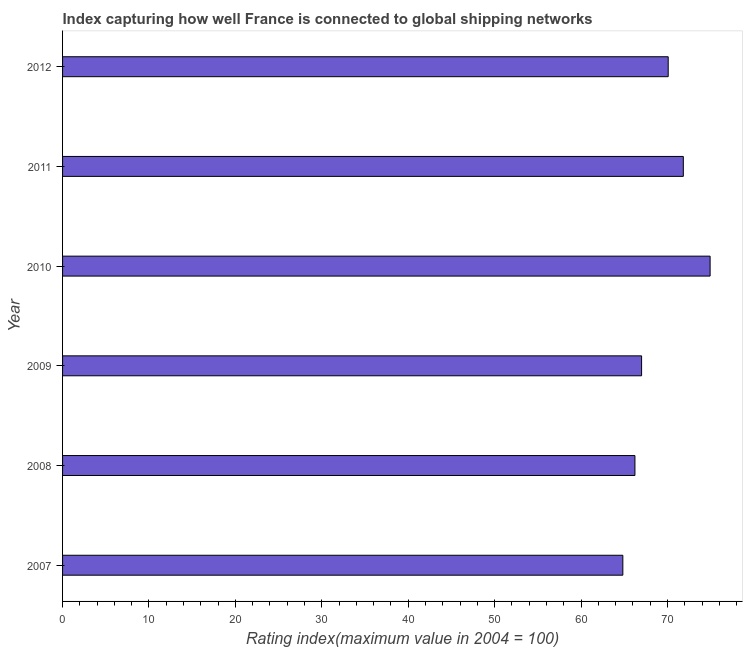Does the graph contain any zero values?
Offer a very short reply. No. What is the title of the graph?
Your answer should be very brief. Index capturing how well France is connected to global shipping networks. What is the label or title of the X-axis?
Ensure brevity in your answer.  Rating index(maximum value in 2004 = 100). What is the label or title of the Y-axis?
Give a very brief answer. Year. What is the liner shipping connectivity index in 2008?
Your response must be concise. 66.24. Across all years, what is the maximum liner shipping connectivity index?
Keep it short and to the point. 74.94. Across all years, what is the minimum liner shipping connectivity index?
Offer a terse response. 64.84. What is the sum of the liner shipping connectivity index?
Your answer should be very brief. 414.96. What is the difference between the liner shipping connectivity index in 2008 and 2012?
Give a very brief answer. -3.85. What is the average liner shipping connectivity index per year?
Provide a short and direct response. 69.16. What is the median liner shipping connectivity index?
Offer a very short reply. 68.55. Do a majority of the years between 2008 and 2007 (inclusive) have liner shipping connectivity index greater than 40 ?
Your answer should be very brief. No. What is the ratio of the liner shipping connectivity index in 2007 to that in 2011?
Give a very brief answer. 0.9. What is the difference between the highest and the second highest liner shipping connectivity index?
Your answer should be compact. 3.1. Is the sum of the liner shipping connectivity index in 2009 and 2011 greater than the maximum liner shipping connectivity index across all years?
Provide a short and direct response. Yes. What is the difference between the highest and the lowest liner shipping connectivity index?
Keep it short and to the point. 10.1. In how many years, is the liner shipping connectivity index greater than the average liner shipping connectivity index taken over all years?
Offer a very short reply. 3. Are all the bars in the graph horizontal?
Your answer should be very brief. Yes. How many years are there in the graph?
Your response must be concise. 6. Are the values on the major ticks of X-axis written in scientific E-notation?
Make the answer very short. No. What is the Rating index(maximum value in 2004 = 100) of 2007?
Offer a very short reply. 64.84. What is the Rating index(maximum value in 2004 = 100) in 2008?
Your answer should be very brief. 66.24. What is the Rating index(maximum value in 2004 = 100) in 2009?
Offer a terse response. 67.01. What is the Rating index(maximum value in 2004 = 100) in 2010?
Provide a succinct answer. 74.94. What is the Rating index(maximum value in 2004 = 100) in 2011?
Provide a succinct answer. 71.84. What is the Rating index(maximum value in 2004 = 100) in 2012?
Offer a very short reply. 70.09. What is the difference between the Rating index(maximum value in 2004 = 100) in 2007 and 2009?
Make the answer very short. -2.17. What is the difference between the Rating index(maximum value in 2004 = 100) in 2007 and 2011?
Ensure brevity in your answer.  -7. What is the difference between the Rating index(maximum value in 2004 = 100) in 2007 and 2012?
Make the answer very short. -5.25. What is the difference between the Rating index(maximum value in 2004 = 100) in 2008 and 2009?
Your response must be concise. -0.77. What is the difference between the Rating index(maximum value in 2004 = 100) in 2008 and 2010?
Offer a terse response. -8.7. What is the difference between the Rating index(maximum value in 2004 = 100) in 2008 and 2012?
Your response must be concise. -3.85. What is the difference between the Rating index(maximum value in 2004 = 100) in 2009 and 2010?
Your answer should be compact. -7.93. What is the difference between the Rating index(maximum value in 2004 = 100) in 2009 and 2011?
Your answer should be very brief. -4.83. What is the difference between the Rating index(maximum value in 2004 = 100) in 2009 and 2012?
Provide a short and direct response. -3.08. What is the difference between the Rating index(maximum value in 2004 = 100) in 2010 and 2012?
Offer a very short reply. 4.85. What is the difference between the Rating index(maximum value in 2004 = 100) in 2011 and 2012?
Keep it short and to the point. 1.75. What is the ratio of the Rating index(maximum value in 2004 = 100) in 2007 to that in 2008?
Provide a succinct answer. 0.98. What is the ratio of the Rating index(maximum value in 2004 = 100) in 2007 to that in 2010?
Offer a terse response. 0.86. What is the ratio of the Rating index(maximum value in 2004 = 100) in 2007 to that in 2011?
Give a very brief answer. 0.9. What is the ratio of the Rating index(maximum value in 2004 = 100) in 2007 to that in 2012?
Your answer should be very brief. 0.93. What is the ratio of the Rating index(maximum value in 2004 = 100) in 2008 to that in 2009?
Offer a terse response. 0.99. What is the ratio of the Rating index(maximum value in 2004 = 100) in 2008 to that in 2010?
Provide a succinct answer. 0.88. What is the ratio of the Rating index(maximum value in 2004 = 100) in 2008 to that in 2011?
Your answer should be compact. 0.92. What is the ratio of the Rating index(maximum value in 2004 = 100) in 2008 to that in 2012?
Give a very brief answer. 0.94. What is the ratio of the Rating index(maximum value in 2004 = 100) in 2009 to that in 2010?
Ensure brevity in your answer.  0.89. What is the ratio of the Rating index(maximum value in 2004 = 100) in 2009 to that in 2011?
Make the answer very short. 0.93. What is the ratio of the Rating index(maximum value in 2004 = 100) in 2009 to that in 2012?
Make the answer very short. 0.96. What is the ratio of the Rating index(maximum value in 2004 = 100) in 2010 to that in 2011?
Give a very brief answer. 1.04. What is the ratio of the Rating index(maximum value in 2004 = 100) in 2010 to that in 2012?
Your answer should be compact. 1.07. 